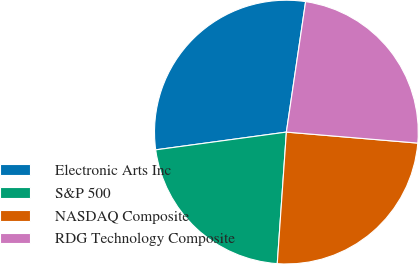Convert chart. <chart><loc_0><loc_0><loc_500><loc_500><pie_chart><fcel>Electronic Arts Inc<fcel>S&P 500<fcel>NASDAQ Composite<fcel>RDG Technology Composite<nl><fcel>29.48%<fcel>21.75%<fcel>24.77%<fcel>24.0%<nl></chart> 